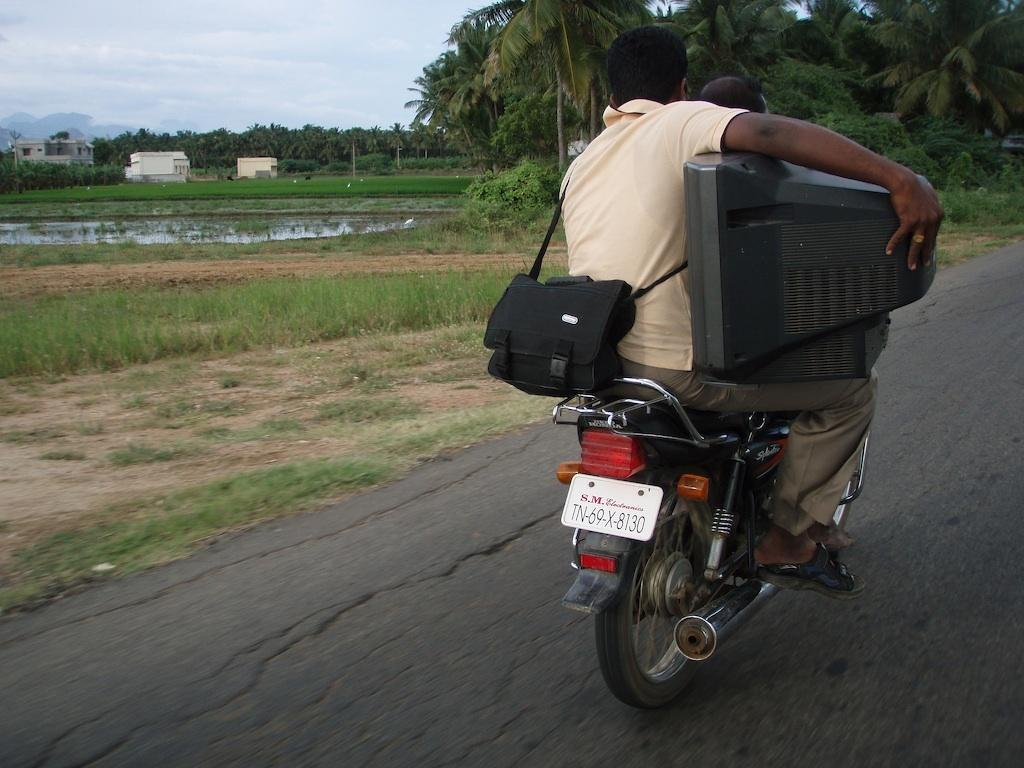What are the two people doing in the image? Two people are travelling on a bike in the image. What are they holding while riding the bike? They are holding a TV in their hands. What can be seen on the left side of the image? There are trees on the left side of the image. What else is visible in the image besides the people and trees? There is water and the sky visible in the image. What type of breakfast is being prepared by the expert in the image? There is no expert or breakfast preparation visible in the image. 